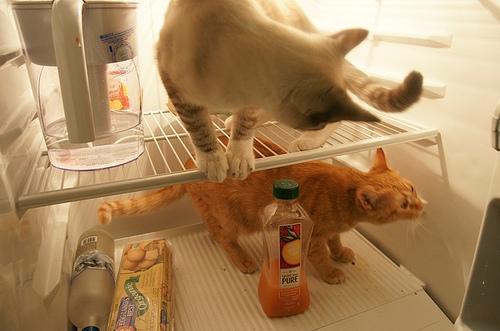How many cats are there?
Give a very brief answer. 2. How many bottles can be seen?
Give a very brief answer. 2. How many cats are visible?
Give a very brief answer. 2. How many green buses can you see?
Give a very brief answer. 0. 